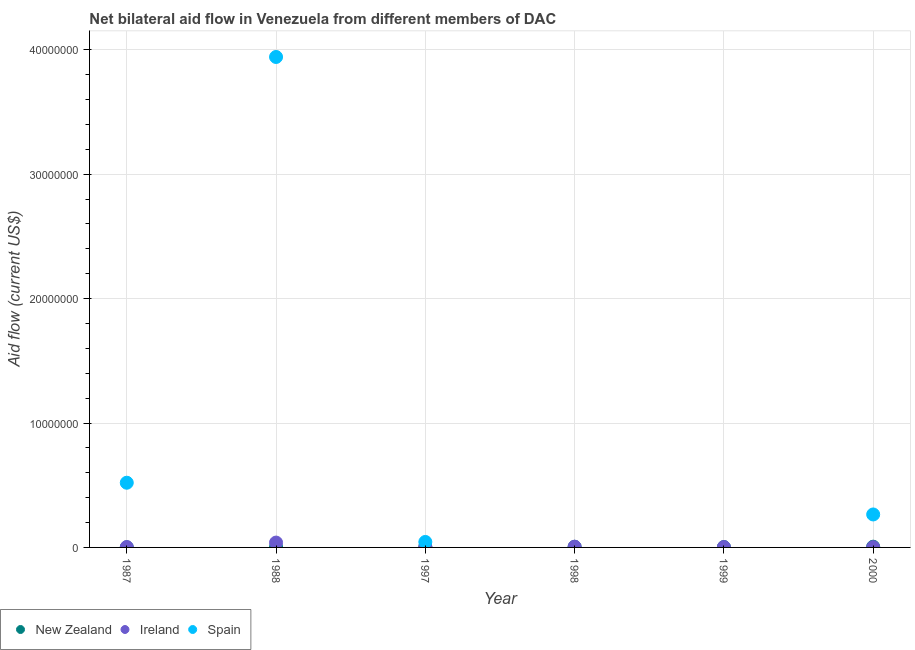Across all years, what is the maximum amount of aid provided by new zealand?
Your answer should be compact. 6.00e+04. Across all years, what is the minimum amount of aid provided by ireland?
Your answer should be compact. 2.00e+04. In which year was the amount of aid provided by spain maximum?
Keep it short and to the point. 1988. What is the total amount of aid provided by spain in the graph?
Keep it short and to the point. 4.77e+07. What is the difference between the amount of aid provided by ireland in 1997 and the amount of aid provided by spain in 1999?
Offer a very short reply. 4.00e+04. What is the average amount of aid provided by new zealand per year?
Ensure brevity in your answer.  3.83e+04. In the year 1997, what is the difference between the amount of aid provided by ireland and amount of aid provided by spain?
Your answer should be very brief. -4.00e+05. What is the difference between the highest and the lowest amount of aid provided by ireland?
Offer a terse response. 3.70e+05. In how many years, is the amount of aid provided by spain greater than the average amount of aid provided by spain taken over all years?
Your response must be concise. 1. Is it the case that in every year, the sum of the amount of aid provided by new zealand and amount of aid provided by ireland is greater than the amount of aid provided by spain?
Your answer should be compact. No. Are the values on the major ticks of Y-axis written in scientific E-notation?
Your answer should be very brief. No. Does the graph contain any zero values?
Ensure brevity in your answer.  Yes. Does the graph contain grids?
Your answer should be compact. Yes. Where does the legend appear in the graph?
Your answer should be very brief. Bottom left. How are the legend labels stacked?
Offer a terse response. Horizontal. What is the title of the graph?
Ensure brevity in your answer.  Net bilateral aid flow in Venezuela from different members of DAC. What is the Aid flow (current US$) in New Zealand in 1987?
Provide a succinct answer. 10000. What is the Aid flow (current US$) in Ireland in 1987?
Make the answer very short. 3.00e+04. What is the Aid flow (current US$) in Spain in 1987?
Your response must be concise. 5.20e+06. What is the Aid flow (current US$) of Spain in 1988?
Offer a very short reply. 3.94e+07. What is the Aid flow (current US$) of Ireland in 1997?
Offer a terse response. 4.00e+04. What is the Aid flow (current US$) in Spain in 1997?
Give a very brief answer. 4.40e+05. What is the Aid flow (current US$) of New Zealand in 1998?
Offer a terse response. 5.00e+04. What is the Aid flow (current US$) of New Zealand in 2000?
Offer a terse response. 6.00e+04. What is the Aid flow (current US$) in Spain in 2000?
Offer a terse response. 2.65e+06. Across all years, what is the maximum Aid flow (current US$) of New Zealand?
Offer a very short reply. 6.00e+04. Across all years, what is the maximum Aid flow (current US$) in Spain?
Provide a short and direct response. 3.94e+07. Across all years, what is the minimum Aid flow (current US$) in New Zealand?
Offer a very short reply. 10000. What is the total Aid flow (current US$) in Ireland in the graph?
Give a very brief answer. 5.70e+05. What is the total Aid flow (current US$) of Spain in the graph?
Ensure brevity in your answer.  4.77e+07. What is the difference between the Aid flow (current US$) in New Zealand in 1987 and that in 1988?
Keep it short and to the point. -2.00e+04. What is the difference between the Aid flow (current US$) of Ireland in 1987 and that in 1988?
Offer a very short reply. -3.60e+05. What is the difference between the Aid flow (current US$) in Spain in 1987 and that in 1988?
Provide a succinct answer. -3.42e+07. What is the difference between the Aid flow (current US$) in New Zealand in 1987 and that in 1997?
Ensure brevity in your answer.  -4.00e+04. What is the difference between the Aid flow (current US$) in Spain in 1987 and that in 1997?
Your answer should be very brief. 4.76e+06. What is the difference between the Aid flow (current US$) of New Zealand in 1987 and that in 1998?
Your response must be concise. -4.00e+04. What is the difference between the Aid flow (current US$) of New Zealand in 1987 and that in 1999?
Give a very brief answer. -2.00e+04. What is the difference between the Aid flow (current US$) of Spain in 1987 and that in 2000?
Your answer should be compact. 2.55e+06. What is the difference between the Aid flow (current US$) in New Zealand in 1988 and that in 1997?
Provide a succinct answer. -2.00e+04. What is the difference between the Aid flow (current US$) in Ireland in 1988 and that in 1997?
Your answer should be very brief. 3.50e+05. What is the difference between the Aid flow (current US$) in Spain in 1988 and that in 1997?
Your response must be concise. 3.90e+07. What is the difference between the Aid flow (current US$) in New Zealand in 1988 and that in 2000?
Your answer should be very brief. -3.00e+04. What is the difference between the Aid flow (current US$) in Spain in 1988 and that in 2000?
Your response must be concise. 3.68e+07. What is the difference between the Aid flow (current US$) of New Zealand in 1997 and that in 1998?
Your response must be concise. 0. What is the difference between the Aid flow (current US$) of Ireland in 1997 and that in 1999?
Make the answer very short. 10000. What is the difference between the Aid flow (current US$) of New Zealand in 1997 and that in 2000?
Make the answer very short. -10000. What is the difference between the Aid flow (current US$) of Spain in 1997 and that in 2000?
Offer a very short reply. -2.21e+06. What is the difference between the Aid flow (current US$) of New Zealand in 1998 and that in 1999?
Offer a terse response. 2.00e+04. What is the difference between the Aid flow (current US$) of New Zealand in 1999 and that in 2000?
Offer a terse response. -3.00e+04. What is the difference between the Aid flow (current US$) of Ireland in 1999 and that in 2000?
Your response must be concise. 10000. What is the difference between the Aid flow (current US$) in New Zealand in 1987 and the Aid flow (current US$) in Ireland in 1988?
Offer a terse response. -3.80e+05. What is the difference between the Aid flow (current US$) in New Zealand in 1987 and the Aid flow (current US$) in Spain in 1988?
Make the answer very short. -3.94e+07. What is the difference between the Aid flow (current US$) of Ireland in 1987 and the Aid flow (current US$) of Spain in 1988?
Make the answer very short. -3.94e+07. What is the difference between the Aid flow (current US$) in New Zealand in 1987 and the Aid flow (current US$) in Ireland in 1997?
Your response must be concise. -3.00e+04. What is the difference between the Aid flow (current US$) in New Zealand in 1987 and the Aid flow (current US$) in Spain in 1997?
Ensure brevity in your answer.  -4.30e+05. What is the difference between the Aid flow (current US$) of Ireland in 1987 and the Aid flow (current US$) of Spain in 1997?
Keep it short and to the point. -4.10e+05. What is the difference between the Aid flow (current US$) in New Zealand in 1987 and the Aid flow (current US$) in Ireland in 1999?
Make the answer very short. -2.00e+04. What is the difference between the Aid flow (current US$) in New Zealand in 1987 and the Aid flow (current US$) in Ireland in 2000?
Give a very brief answer. -10000. What is the difference between the Aid flow (current US$) in New Zealand in 1987 and the Aid flow (current US$) in Spain in 2000?
Provide a short and direct response. -2.64e+06. What is the difference between the Aid flow (current US$) in Ireland in 1987 and the Aid flow (current US$) in Spain in 2000?
Keep it short and to the point. -2.62e+06. What is the difference between the Aid flow (current US$) of New Zealand in 1988 and the Aid flow (current US$) of Ireland in 1997?
Your answer should be compact. -10000. What is the difference between the Aid flow (current US$) of New Zealand in 1988 and the Aid flow (current US$) of Spain in 1997?
Provide a succinct answer. -4.10e+05. What is the difference between the Aid flow (current US$) of Ireland in 1988 and the Aid flow (current US$) of Spain in 1997?
Provide a succinct answer. -5.00e+04. What is the difference between the Aid flow (current US$) of New Zealand in 1988 and the Aid flow (current US$) of Ireland in 1998?
Keep it short and to the point. -3.00e+04. What is the difference between the Aid flow (current US$) in New Zealand in 1988 and the Aid flow (current US$) in Spain in 2000?
Keep it short and to the point. -2.62e+06. What is the difference between the Aid flow (current US$) of Ireland in 1988 and the Aid flow (current US$) of Spain in 2000?
Provide a short and direct response. -2.26e+06. What is the difference between the Aid flow (current US$) of New Zealand in 1997 and the Aid flow (current US$) of Ireland in 2000?
Provide a short and direct response. 3.00e+04. What is the difference between the Aid flow (current US$) in New Zealand in 1997 and the Aid flow (current US$) in Spain in 2000?
Your answer should be compact. -2.60e+06. What is the difference between the Aid flow (current US$) in Ireland in 1997 and the Aid flow (current US$) in Spain in 2000?
Provide a short and direct response. -2.61e+06. What is the difference between the Aid flow (current US$) in New Zealand in 1998 and the Aid flow (current US$) in Ireland in 1999?
Provide a succinct answer. 2.00e+04. What is the difference between the Aid flow (current US$) of New Zealand in 1998 and the Aid flow (current US$) of Spain in 2000?
Offer a very short reply. -2.60e+06. What is the difference between the Aid flow (current US$) in Ireland in 1998 and the Aid flow (current US$) in Spain in 2000?
Offer a very short reply. -2.59e+06. What is the difference between the Aid flow (current US$) of New Zealand in 1999 and the Aid flow (current US$) of Spain in 2000?
Your answer should be compact. -2.62e+06. What is the difference between the Aid flow (current US$) in Ireland in 1999 and the Aid flow (current US$) in Spain in 2000?
Make the answer very short. -2.62e+06. What is the average Aid flow (current US$) of New Zealand per year?
Provide a succinct answer. 3.83e+04. What is the average Aid flow (current US$) of Ireland per year?
Offer a terse response. 9.50e+04. What is the average Aid flow (current US$) in Spain per year?
Offer a terse response. 7.95e+06. In the year 1987, what is the difference between the Aid flow (current US$) of New Zealand and Aid flow (current US$) of Spain?
Keep it short and to the point. -5.19e+06. In the year 1987, what is the difference between the Aid flow (current US$) in Ireland and Aid flow (current US$) in Spain?
Ensure brevity in your answer.  -5.17e+06. In the year 1988, what is the difference between the Aid flow (current US$) in New Zealand and Aid flow (current US$) in Ireland?
Your answer should be compact. -3.60e+05. In the year 1988, what is the difference between the Aid flow (current US$) in New Zealand and Aid flow (current US$) in Spain?
Ensure brevity in your answer.  -3.94e+07. In the year 1988, what is the difference between the Aid flow (current US$) in Ireland and Aid flow (current US$) in Spain?
Your answer should be compact. -3.90e+07. In the year 1997, what is the difference between the Aid flow (current US$) of New Zealand and Aid flow (current US$) of Spain?
Provide a succinct answer. -3.90e+05. In the year 1997, what is the difference between the Aid flow (current US$) of Ireland and Aid flow (current US$) of Spain?
Give a very brief answer. -4.00e+05. In the year 1998, what is the difference between the Aid flow (current US$) of New Zealand and Aid flow (current US$) of Ireland?
Offer a very short reply. -10000. In the year 2000, what is the difference between the Aid flow (current US$) of New Zealand and Aid flow (current US$) of Ireland?
Offer a very short reply. 4.00e+04. In the year 2000, what is the difference between the Aid flow (current US$) of New Zealand and Aid flow (current US$) of Spain?
Your answer should be compact. -2.59e+06. In the year 2000, what is the difference between the Aid flow (current US$) of Ireland and Aid flow (current US$) of Spain?
Keep it short and to the point. -2.63e+06. What is the ratio of the Aid flow (current US$) of Ireland in 1987 to that in 1988?
Give a very brief answer. 0.08. What is the ratio of the Aid flow (current US$) of Spain in 1987 to that in 1988?
Give a very brief answer. 0.13. What is the ratio of the Aid flow (current US$) of Spain in 1987 to that in 1997?
Make the answer very short. 11.82. What is the ratio of the Aid flow (current US$) of Ireland in 1987 to that in 1999?
Keep it short and to the point. 1. What is the ratio of the Aid flow (current US$) of Spain in 1987 to that in 2000?
Give a very brief answer. 1.96. What is the ratio of the Aid flow (current US$) of Ireland in 1988 to that in 1997?
Your response must be concise. 9.75. What is the ratio of the Aid flow (current US$) of Spain in 1988 to that in 1997?
Offer a very short reply. 89.59. What is the ratio of the Aid flow (current US$) in Ireland in 1988 to that in 1998?
Ensure brevity in your answer.  6.5. What is the ratio of the Aid flow (current US$) of Ireland in 1988 to that in 1999?
Ensure brevity in your answer.  13. What is the ratio of the Aid flow (current US$) of New Zealand in 1988 to that in 2000?
Your answer should be very brief. 0.5. What is the ratio of the Aid flow (current US$) in Ireland in 1988 to that in 2000?
Your answer should be very brief. 19.5. What is the ratio of the Aid flow (current US$) of Spain in 1988 to that in 2000?
Give a very brief answer. 14.88. What is the ratio of the Aid flow (current US$) of New Zealand in 1997 to that in 1998?
Make the answer very short. 1. What is the ratio of the Aid flow (current US$) in New Zealand in 1997 to that in 1999?
Give a very brief answer. 1.67. What is the ratio of the Aid flow (current US$) in New Zealand in 1997 to that in 2000?
Give a very brief answer. 0.83. What is the ratio of the Aid flow (current US$) of Ireland in 1997 to that in 2000?
Your answer should be compact. 2. What is the ratio of the Aid flow (current US$) in Spain in 1997 to that in 2000?
Ensure brevity in your answer.  0.17. What is the ratio of the Aid flow (current US$) in New Zealand in 1998 to that in 1999?
Provide a short and direct response. 1.67. What is the ratio of the Aid flow (current US$) in Ireland in 1998 to that in 1999?
Make the answer very short. 2. What is the ratio of the Aid flow (current US$) of New Zealand in 1998 to that in 2000?
Offer a very short reply. 0.83. What is the ratio of the Aid flow (current US$) of Ireland in 1998 to that in 2000?
Keep it short and to the point. 3. What is the ratio of the Aid flow (current US$) of New Zealand in 1999 to that in 2000?
Your answer should be very brief. 0.5. What is the difference between the highest and the second highest Aid flow (current US$) in New Zealand?
Offer a very short reply. 10000. What is the difference between the highest and the second highest Aid flow (current US$) in Ireland?
Your answer should be compact. 3.30e+05. What is the difference between the highest and the second highest Aid flow (current US$) of Spain?
Give a very brief answer. 3.42e+07. What is the difference between the highest and the lowest Aid flow (current US$) of New Zealand?
Offer a terse response. 5.00e+04. What is the difference between the highest and the lowest Aid flow (current US$) in Spain?
Offer a terse response. 3.94e+07. 